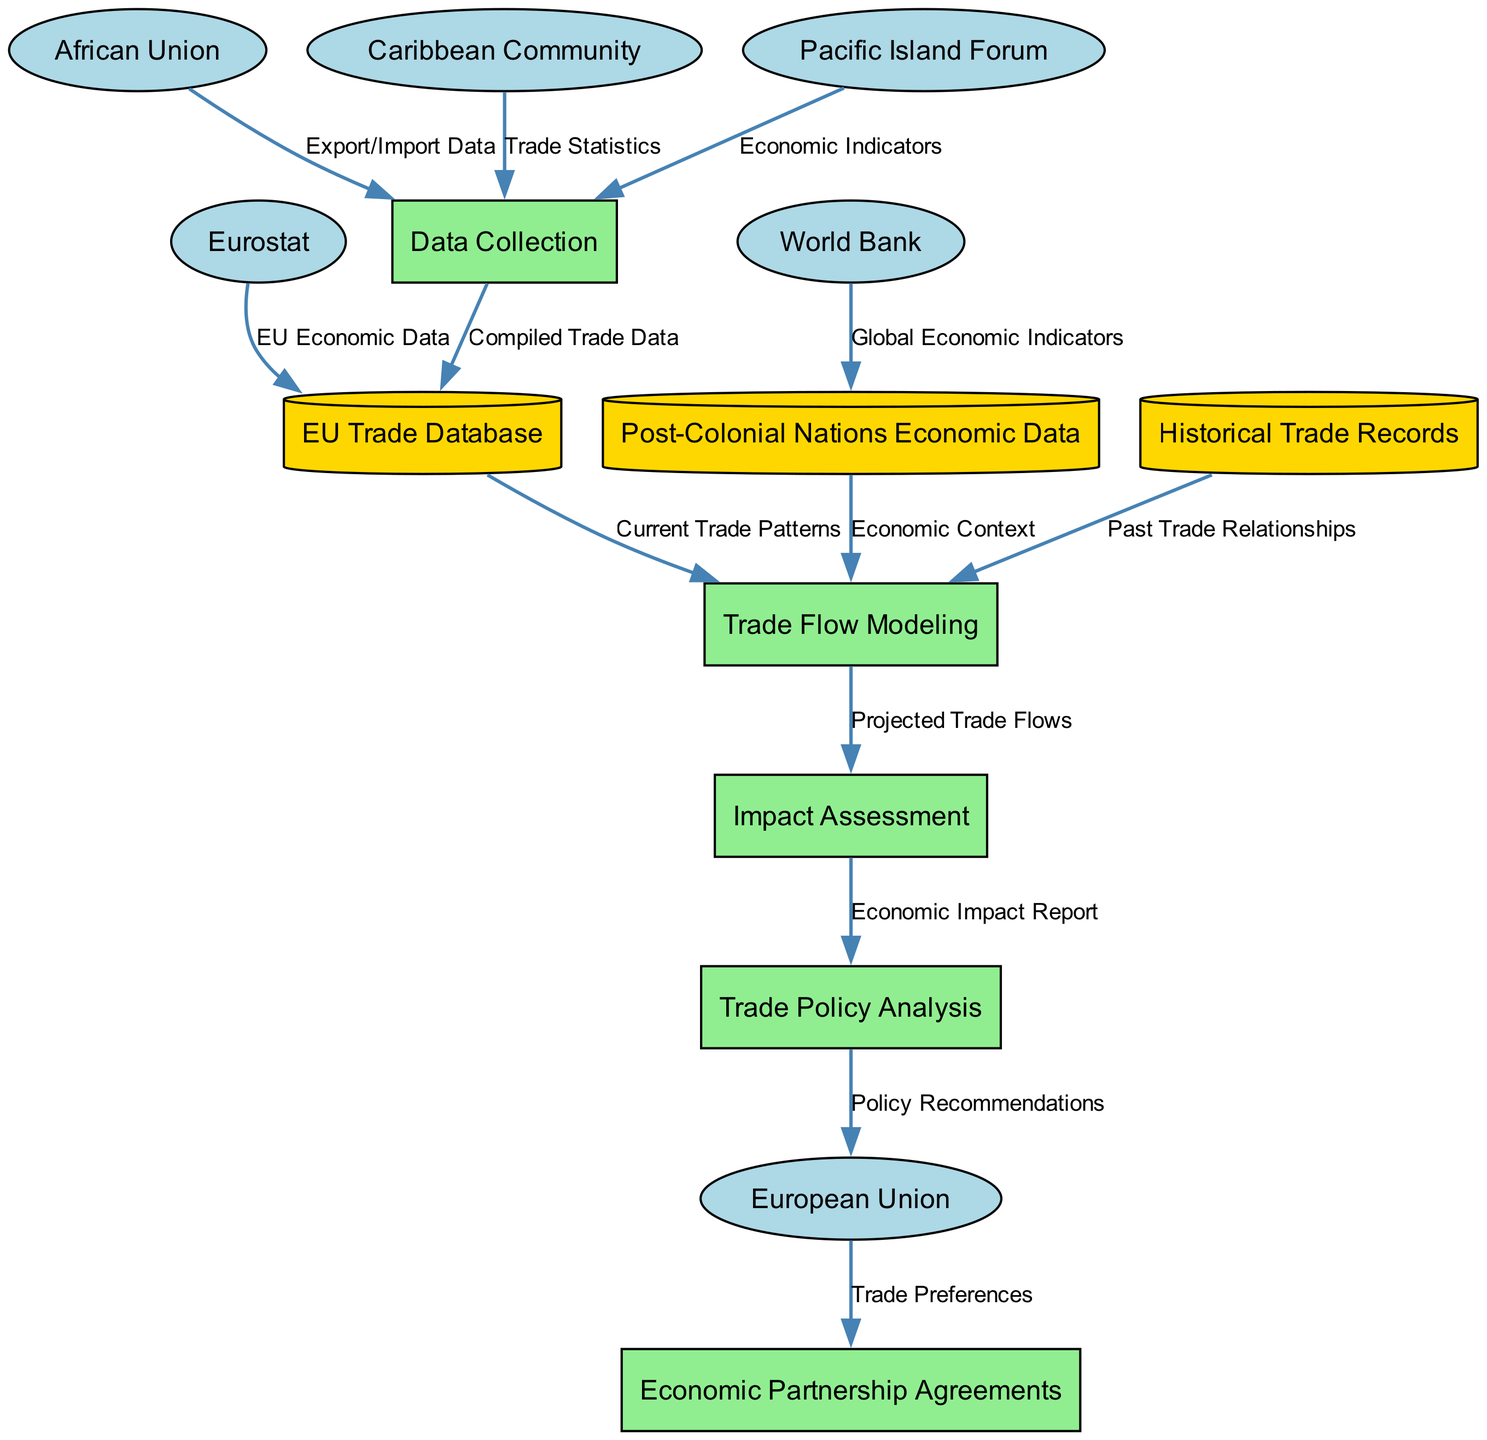What is the total number of entities in the diagram? The diagram includes the European Union, African Union, Caribbean Community, Pacific Island Forum, Eurostat, and World Bank. Counting these, we get a total of six entities.
Answer: 6 What is the label of the flow from the European Union to Economic Partnership Agreements? The flow from the European Union to Economic Partnership Agreements is labeled as "Trade Preferences."
Answer: Trade Preferences How many data stores are present in the diagram? There are three data stores: EU Trade Database, Post-Colonial Nations Economic Data, and Historical Trade Records. We count these to get a total of three data stores.
Answer: 3 From which process does the Economic Impact Report flow to the Trade Policy Analysis? The flow labeled "Economic Impact Report" originates from the Impact Assessment process and goes to the Trade Policy Analysis process.
Answer: Impact Assessment What are the two main data sources for Trade Flow Modeling? The two main data sources for Trade Flow Modeling are the EU Trade Database and Post-Colonial Nations Economic Data, both of which provide essential data for modeling trade flows.
Answer: EU Trade Database, Post-Colonial Nations Economic Data Which entity supplies Global Economic Indicators to the Post-Colonial Nations Economic Data store? The World Bank supplies Global Economic Indicators to the Post-Colonial Nations Economic Data store. This is indicated in the flow where the World Bank's output directly points to that data store.
Answer: World Bank Which process follows the Trade Flow Modeling in the diagram? The process that follows the Trade Flow Modeling in the diagram is the Impact Assessment. The arrows indicate the flow direction, leading from Trade Flow Modeling to Impact Assessment.
Answer: Impact Assessment How many data flows originate from the Data Collection process? Three data flows originate from the Data Collection process, as shown in the diagram where it connects to the EU Trade Database and sends different types of compiled data.
Answer: 3 What are the two types of data the African Union provides in the diagram? The African Union provides "Export/Import Data" to the Data Collection process, which is one type of valuable information used. The other analogously provided data is "Trade Statistics" from the Caribbean Community.
Answer: Export/Import Data, Trade Statistics 